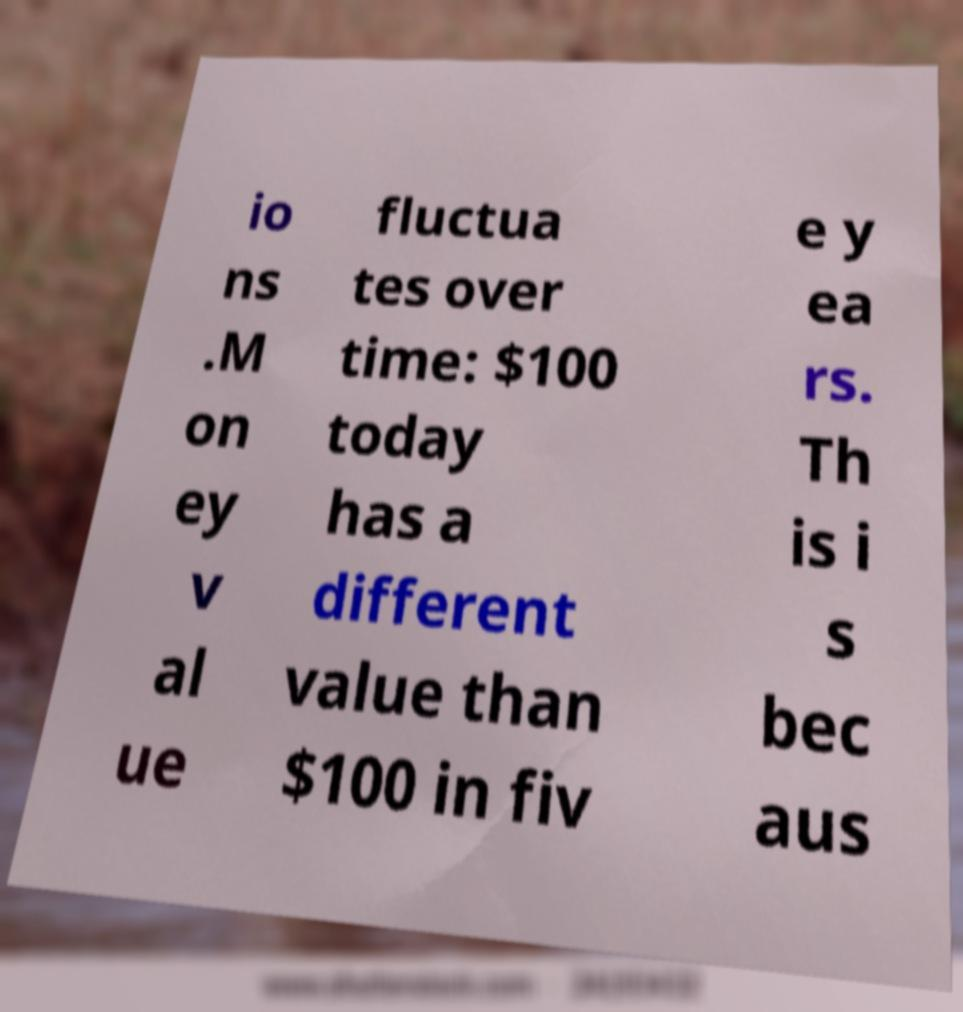For documentation purposes, I need the text within this image transcribed. Could you provide that? io ns .M on ey v al ue fluctua tes over time: $100 today has a different value than $100 in fiv e y ea rs. Th is i s bec aus 